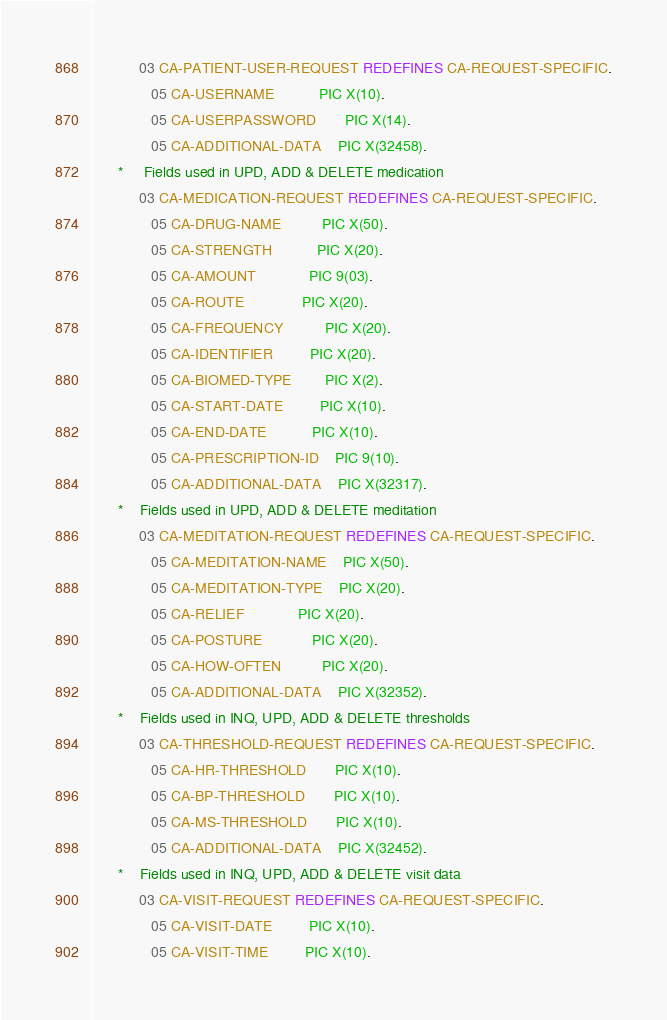Convert code to text. <code><loc_0><loc_0><loc_500><loc_500><_COBOL_>           03 CA-PATIENT-USER-REQUEST REDEFINES CA-REQUEST-SPECIFIC.
              05 CA-USERNAME           PIC X(10).
              05 CA-USERPASSWORD       PIC X(14).
              05 CA-ADDITIONAL-DATA    PIC X(32458).
      *     Fields used in UPD, ADD & DELETE medication
           03 CA-MEDICATION-REQUEST REDEFINES CA-REQUEST-SPECIFIC.
              05 CA-DRUG-NAME          PIC X(50).
              05 CA-STRENGTH           PIC X(20).
              05 CA-AMOUNT             PIC 9(03).
              05 CA-ROUTE              PIC X(20).
              05 CA-FREQUENCY          PIC X(20).
              05 CA-IDENTIFIER         PIC X(20).
              05 CA-BIOMED-TYPE        PIC X(2).
              05 CA-START-DATE         PIC X(10).
              05 CA-END-DATE           PIC X(10).
              05 CA-PRESCRIPTION-ID    PIC 9(10).
              05 CA-ADDITIONAL-DATA    PIC X(32317).
      *    Fields used in UPD, ADD & DELETE meditation
           03 CA-MEDITATION-REQUEST REDEFINES CA-REQUEST-SPECIFIC.
              05 CA-MEDITATION-NAME    PIC X(50).
              05 CA-MEDITATION-TYPE    PIC X(20).
              05 CA-RELIEF             PIC X(20).
              05 CA-POSTURE            PIC X(20).
              05 CA-HOW-OFTEN          PIC X(20).
              05 CA-ADDITIONAL-DATA    PIC X(32352).
      *    Fields used in INQ, UPD, ADD & DELETE thresholds
           03 CA-THRESHOLD-REQUEST REDEFINES CA-REQUEST-SPECIFIC.
              05 CA-HR-THRESHOLD       PIC X(10).
              05 CA-BP-THRESHOLD       PIC X(10).
              05 CA-MS-THRESHOLD       PIC X(10).
              05 CA-ADDITIONAL-DATA    PIC X(32452).
      *    Fields used in INQ, UPD, ADD & DELETE visit data
           03 CA-VISIT-REQUEST REDEFINES CA-REQUEST-SPECIFIC.
              05 CA-VISIT-DATE         PIC X(10).
              05 CA-VISIT-TIME         PIC X(10).</code> 